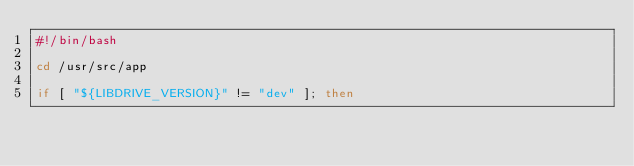Convert code to text. <code><loc_0><loc_0><loc_500><loc_500><_Bash_>#!/bin/bash

cd /usr/src/app

if [ "${LIBDRIVE_VERSION}" != "dev" ]; then</code> 